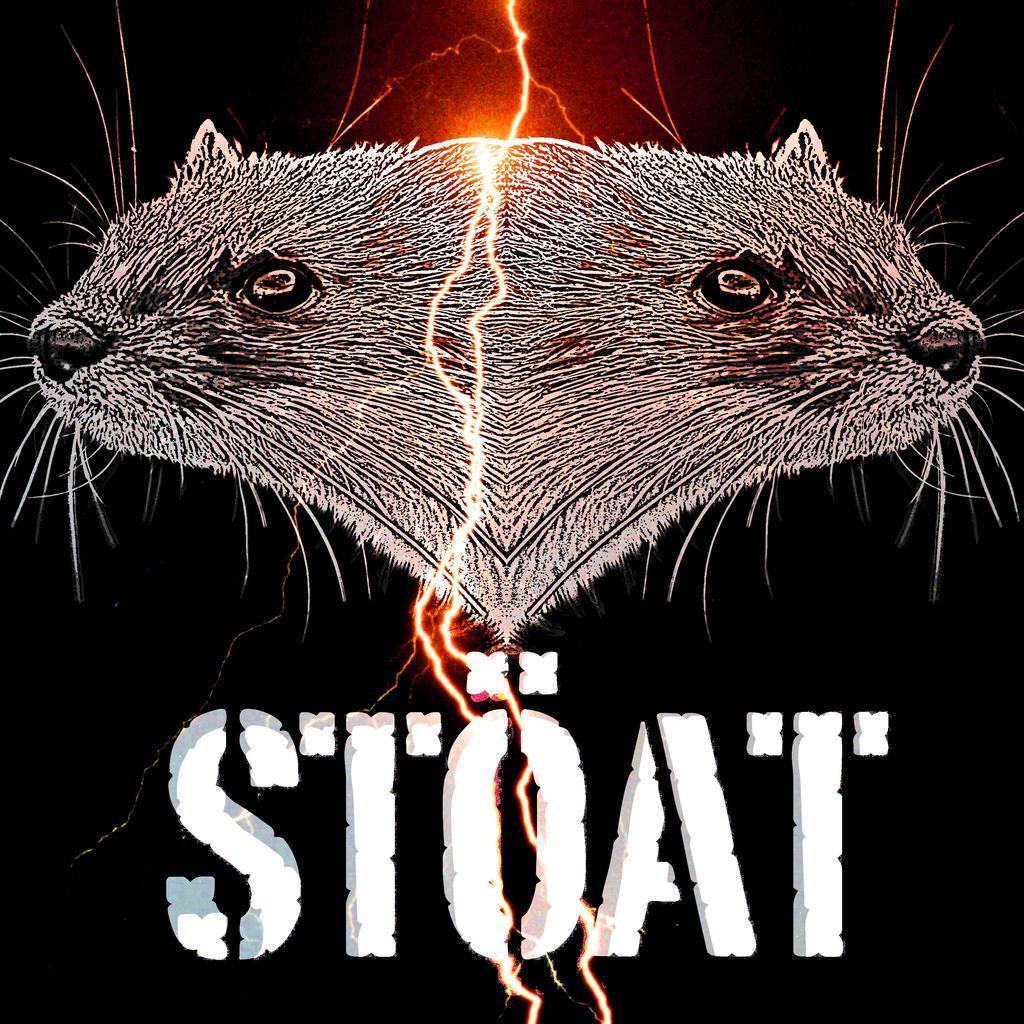Describe this image in one or two sentences. In the picture I can see the heads of two animals and there is a light in between it and there is stoat written below it. 